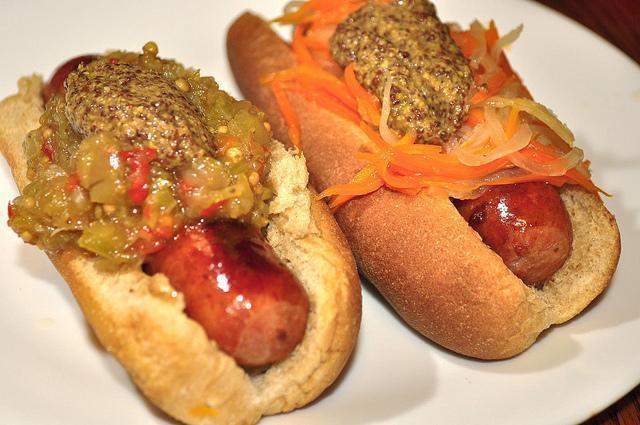How many hot dogs can you see?
Give a very brief answer. 2. How many horses are there?
Give a very brief answer. 0. 